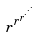<formula> <loc_0><loc_0><loc_500><loc_500>r ^ { r ^ { r ^ { \cdot ^ { \cdot ^ { \cdot } } } } }</formula> 